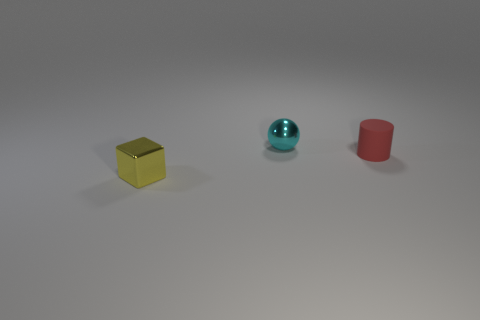Are there any tiny blue things that have the same material as the small yellow object? Upon inspecting the image, it appears that the small aqua-colored sphere could be mistaken for blue in certain light. However, determining whether it has the same material as the yellow cube is not possible through visual inspection alone. To accurately assess their composition, physical examination or additional context is necessary. 